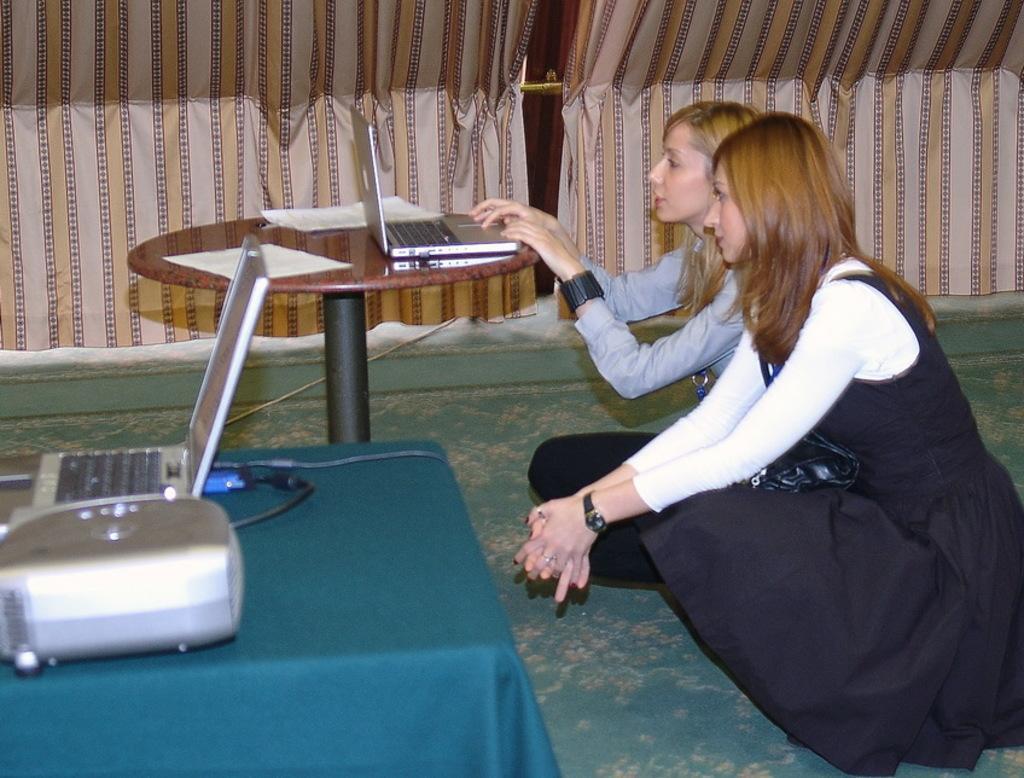How would you summarize this image in a sentence or two? On the right there are two men looking at the table which is on the table. There is also another laptop and projector on the table. In the background there is a curtain. 